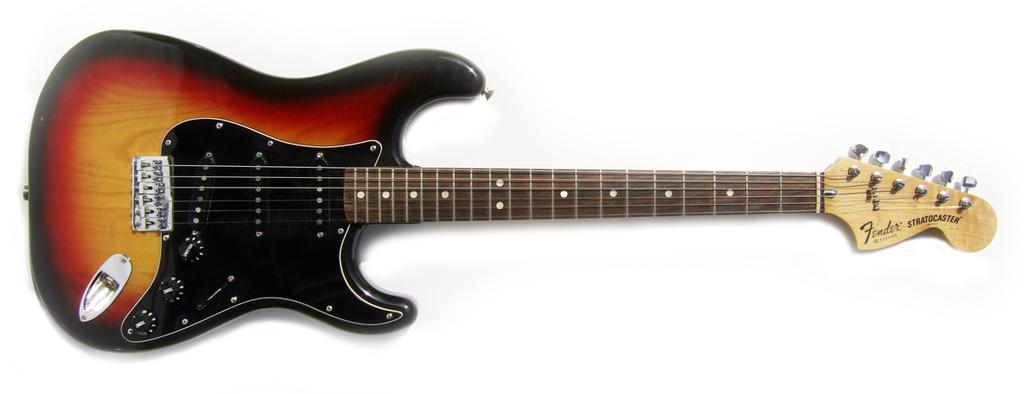What musical instrument is present in the image? There is a guitar in the picture. What colors can be seen on the guitar? The guitar has a red and black color combination. How is the guitar positioned in the image? The guitar is placed in a visually appealing manner. How many bubbles are surrounding the guitar in the image? There are no bubbles present in the image; it only features a guitar with a red and black color combination, placed in a visually appealing manner. 